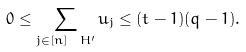Convert formula to latex. <formula><loc_0><loc_0><loc_500><loc_500>0 \leq \sum _ { j \in [ n ] \ H ^ { \prime } } u _ { j } \leq ( t - 1 ) ( q - 1 ) .</formula> 